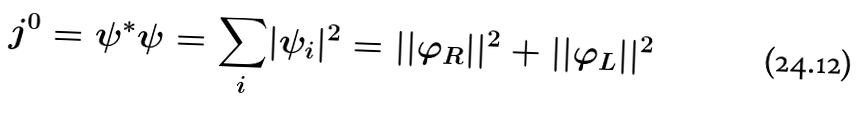Convert formula to latex. <formula><loc_0><loc_0><loc_500><loc_500>j ^ { 0 } = \psi ^ { * } \psi = { \sum _ { i } } | \psi _ { i } | ^ { 2 } = | | \varphi _ { R } | | ^ { 2 } + | | \varphi _ { L } | | ^ { 2 }</formula> 